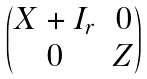Convert formula to latex. <formula><loc_0><loc_0><loc_500><loc_500>\begin{pmatrix} X + I _ { r } & 0 \\ 0 & Z \end{pmatrix}</formula> 